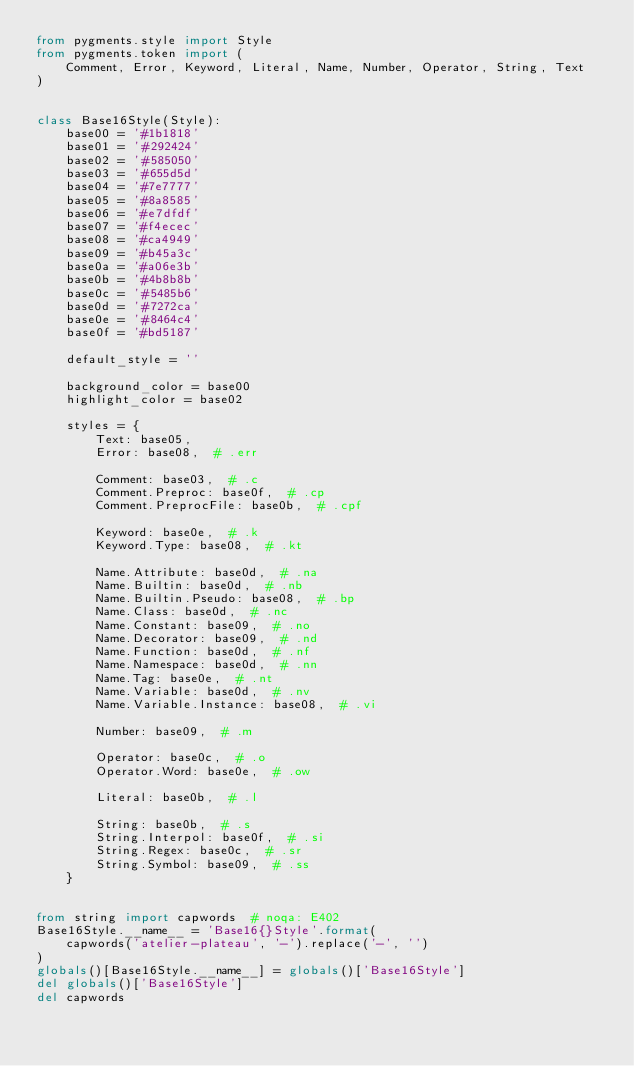<code> <loc_0><loc_0><loc_500><loc_500><_Python_>from pygments.style import Style
from pygments.token import (
    Comment, Error, Keyword, Literal, Name, Number, Operator, String, Text
)


class Base16Style(Style):
    base00 = '#1b1818'
    base01 = '#292424'
    base02 = '#585050'
    base03 = '#655d5d'
    base04 = '#7e7777'
    base05 = '#8a8585'
    base06 = '#e7dfdf'
    base07 = '#f4ecec'
    base08 = '#ca4949'
    base09 = '#b45a3c'
    base0a = '#a06e3b'
    base0b = '#4b8b8b'
    base0c = '#5485b6'
    base0d = '#7272ca'
    base0e = '#8464c4'
    base0f = '#bd5187'

    default_style = ''

    background_color = base00
    highlight_color = base02

    styles = {
        Text: base05,
        Error: base08,  # .err

        Comment: base03,  # .c
        Comment.Preproc: base0f,  # .cp
        Comment.PreprocFile: base0b,  # .cpf

        Keyword: base0e,  # .k
        Keyword.Type: base08,  # .kt

        Name.Attribute: base0d,  # .na
        Name.Builtin: base0d,  # .nb
        Name.Builtin.Pseudo: base08,  # .bp
        Name.Class: base0d,  # .nc
        Name.Constant: base09,  # .no
        Name.Decorator: base09,  # .nd
        Name.Function: base0d,  # .nf
        Name.Namespace: base0d,  # .nn
        Name.Tag: base0e,  # .nt
        Name.Variable: base0d,  # .nv
        Name.Variable.Instance: base08,  # .vi

        Number: base09,  # .m

        Operator: base0c,  # .o
        Operator.Word: base0e,  # .ow

        Literal: base0b,  # .l

        String: base0b,  # .s
        String.Interpol: base0f,  # .si
        String.Regex: base0c,  # .sr
        String.Symbol: base09,  # .ss
    }


from string import capwords  # noqa: E402
Base16Style.__name__ = 'Base16{}Style'.format(
    capwords('atelier-plateau', '-').replace('-', '')
)
globals()[Base16Style.__name__] = globals()['Base16Style']
del globals()['Base16Style']
del capwords
</code> 